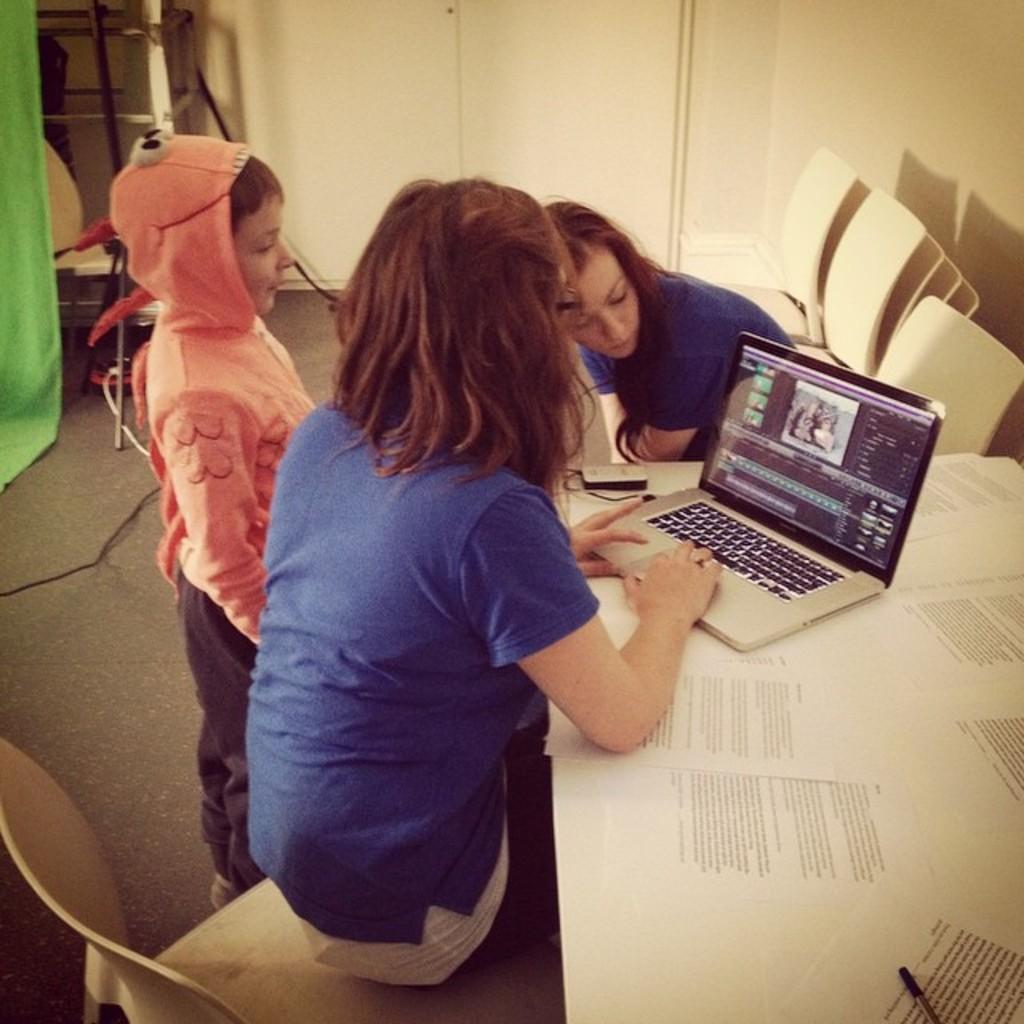In one or two sentences, can you explain what this image depicts? In this picture we can see two women sitting on chairs and a boy standing on the floor and in front of them on the table we can see papers, pen, laptop and in the background we can see wall. 